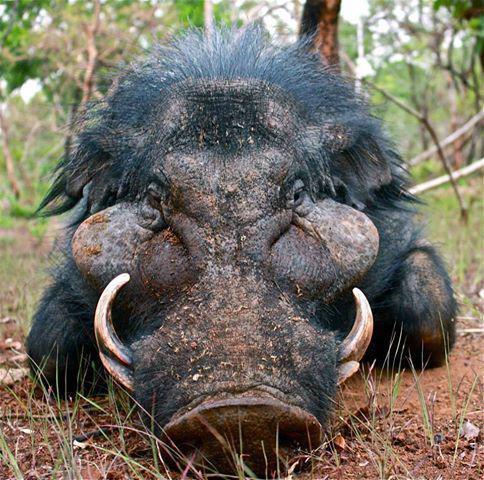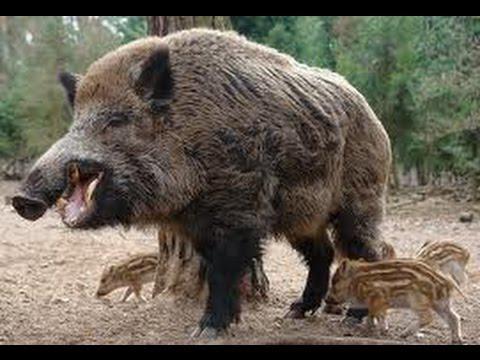The first image is the image on the left, the second image is the image on the right. For the images displayed, is the sentence "An animals is walking with its babies." factually correct? Answer yes or no. Yes. 